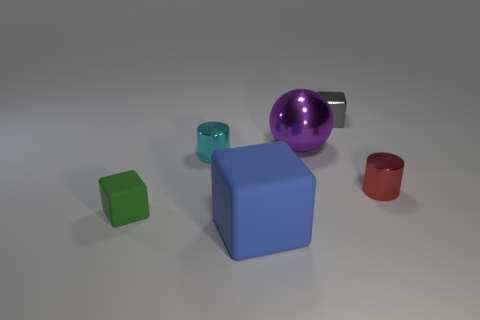How many things are matte objects that are on the left side of the blue rubber object or metallic cylinders that are to the right of the small gray block?
Offer a very short reply. 2. There is another thing that is made of the same material as the tiny green object; what is its shape?
Provide a succinct answer. Cube. Are there any other things that have the same color as the big sphere?
Ensure brevity in your answer.  No. There is a green object that is the same shape as the tiny gray thing; what material is it?
Provide a succinct answer. Rubber. How many other objects are there of the same size as the blue block?
Keep it short and to the point. 1. What material is the gray cube?
Offer a very short reply. Metal. Are there more things that are in front of the large blue block than blue things?
Ensure brevity in your answer.  No. Is there a big matte object?
Ensure brevity in your answer.  Yes. How many other things are the same shape as the purple metallic object?
Provide a succinct answer. 0. Is the color of the big thing in front of the tiny red object the same as the shiny cylinder that is left of the small red cylinder?
Offer a terse response. No. 